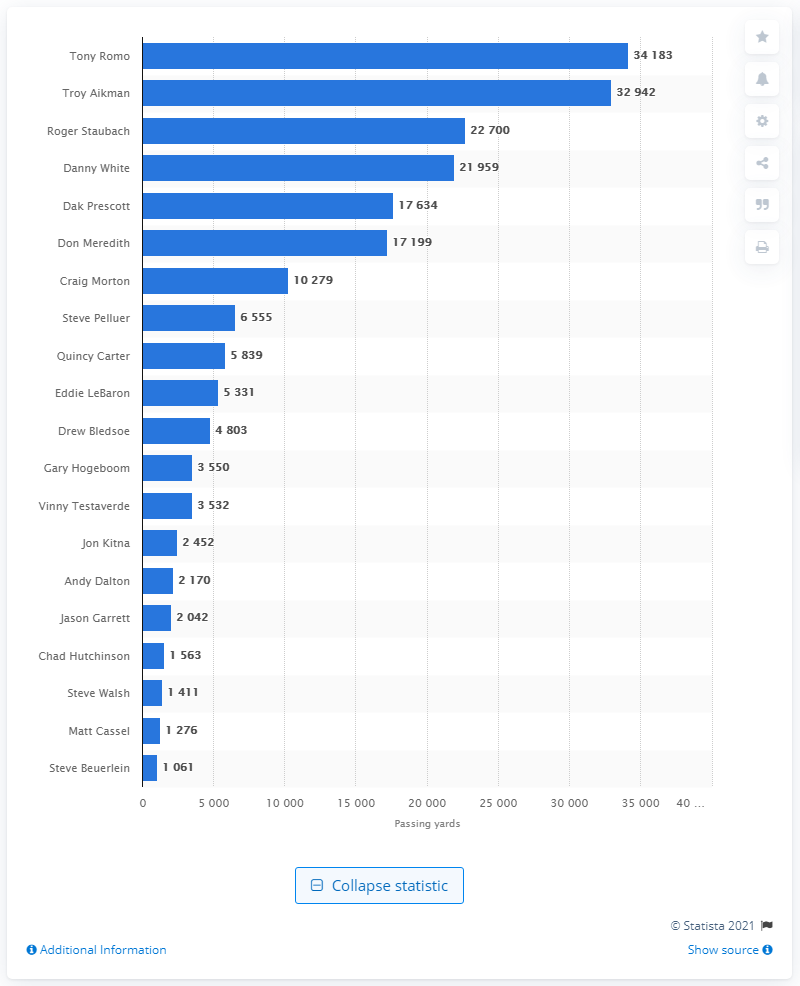Indicate a few pertinent items in this graphic. Tony Romo is the career passing leader of the Dallas Cowboys. 